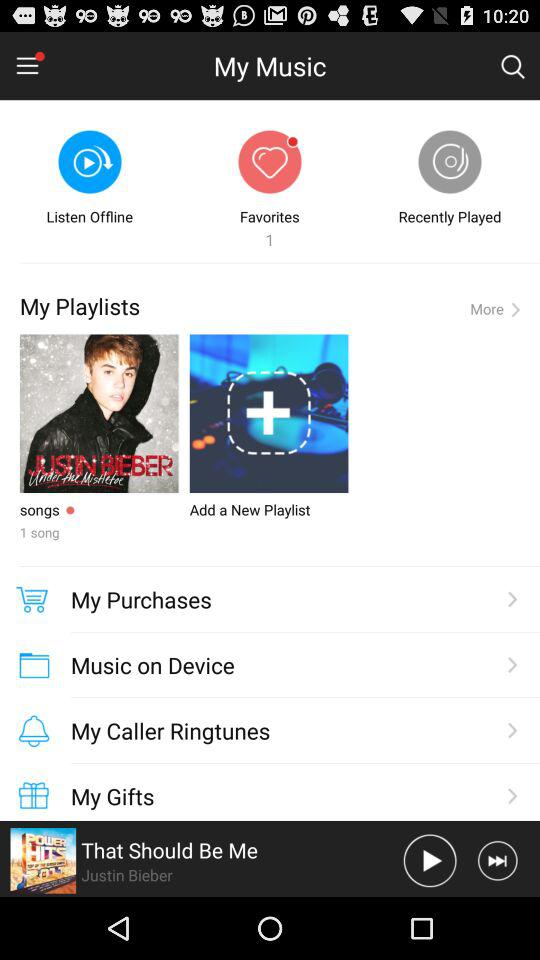How many songs are there in "My Playlists"? There is 1 song in "My Playlists". 